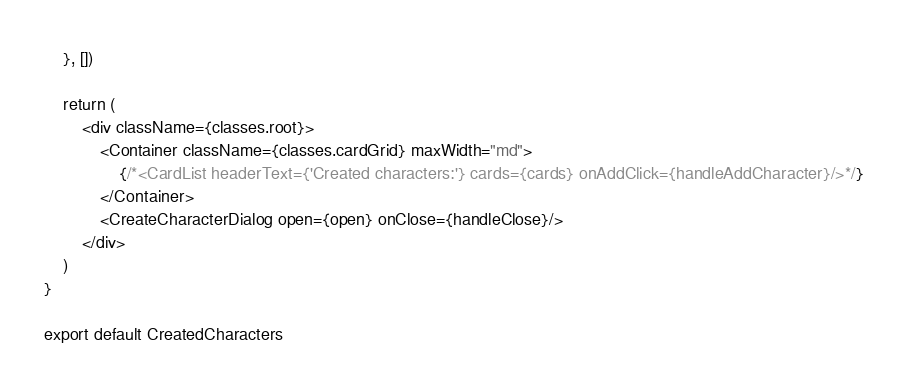<code> <loc_0><loc_0><loc_500><loc_500><_TypeScript_>    }, [])

    return (
        <div className={classes.root}>
            <Container className={classes.cardGrid} maxWidth="md">
                {/*<CardList headerText={'Created characters:'} cards={cards} onAddClick={handleAddCharacter}/>*/}
            </Container>
            <CreateCharacterDialog open={open} onClose={handleClose}/>
        </div>
    )
}

export default CreatedCharacters</code> 